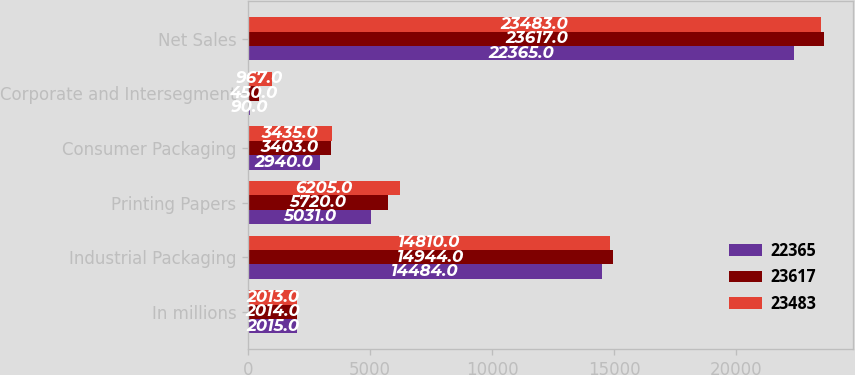Convert chart. <chart><loc_0><loc_0><loc_500><loc_500><stacked_bar_chart><ecel><fcel>In millions<fcel>Industrial Packaging<fcel>Printing Papers<fcel>Consumer Packaging<fcel>Corporate and Intersegment<fcel>Net Sales<nl><fcel>22365<fcel>2015<fcel>14484<fcel>5031<fcel>2940<fcel>90<fcel>22365<nl><fcel>23617<fcel>2014<fcel>14944<fcel>5720<fcel>3403<fcel>450<fcel>23617<nl><fcel>23483<fcel>2013<fcel>14810<fcel>6205<fcel>3435<fcel>967<fcel>23483<nl></chart> 